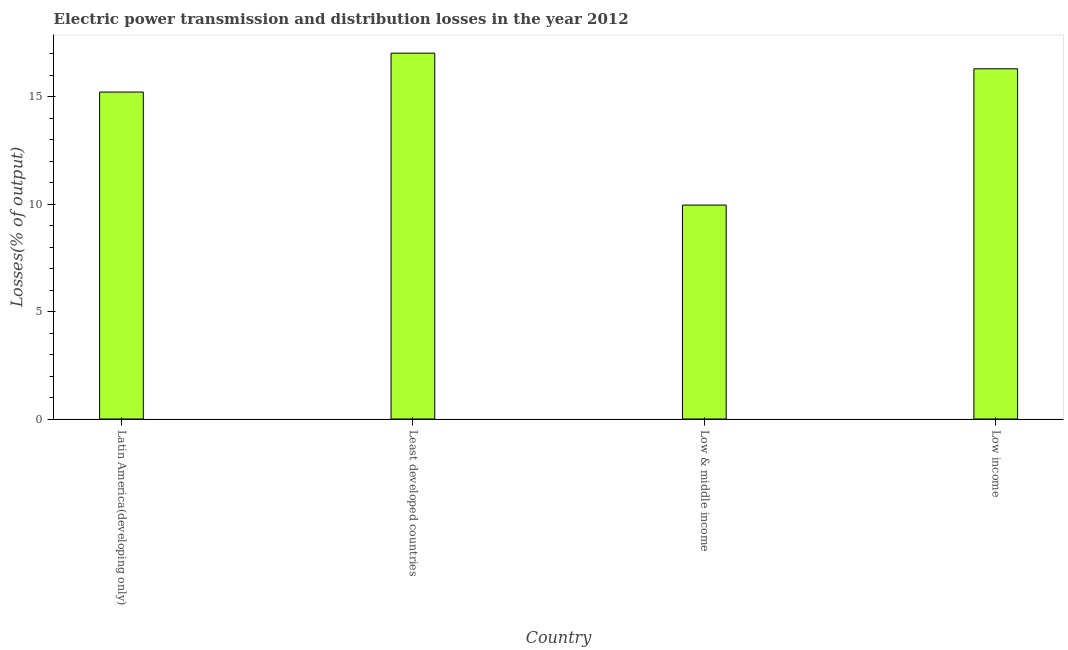Does the graph contain any zero values?
Give a very brief answer. No. What is the title of the graph?
Make the answer very short. Electric power transmission and distribution losses in the year 2012. What is the label or title of the Y-axis?
Offer a very short reply. Losses(% of output). What is the electric power transmission and distribution losses in Latin America(developing only)?
Give a very brief answer. 15.21. Across all countries, what is the maximum electric power transmission and distribution losses?
Keep it short and to the point. 17.02. Across all countries, what is the minimum electric power transmission and distribution losses?
Your response must be concise. 9.95. In which country was the electric power transmission and distribution losses maximum?
Make the answer very short. Least developed countries. In which country was the electric power transmission and distribution losses minimum?
Your answer should be very brief. Low & middle income. What is the sum of the electric power transmission and distribution losses?
Your response must be concise. 58.47. What is the difference between the electric power transmission and distribution losses in Low & middle income and Low income?
Your response must be concise. -6.34. What is the average electric power transmission and distribution losses per country?
Your answer should be very brief. 14.62. What is the median electric power transmission and distribution losses?
Your response must be concise. 15.75. In how many countries, is the electric power transmission and distribution losses greater than 15 %?
Provide a short and direct response. 3. What is the ratio of the electric power transmission and distribution losses in Low & middle income to that in Low income?
Provide a short and direct response. 0.61. Is the electric power transmission and distribution losses in Latin America(developing only) less than that in Low income?
Keep it short and to the point. Yes. Is the difference between the electric power transmission and distribution losses in Latin America(developing only) and Least developed countries greater than the difference between any two countries?
Keep it short and to the point. No. What is the difference between the highest and the second highest electric power transmission and distribution losses?
Offer a very short reply. 0.73. What is the difference between the highest and the lowest electric power transmission and distribution losses?
Your answer should be compact. 7.07. Are all the bars in the graph horizontal?
Your answer should be compact. No. Are the values on the major ticks of Y-axis written in scientific E-notation?
Make the answer very short. No. What is the Losses(% of output) of Latin America(developing only)?
Your answer should be very brief. 15.21. What is the Losses(% of output) in Least developed countries?
Your answer should be very brief. 17.02. What is the Losses(% of output) of Low & middle income?
Offer a very short reply. 9.95. What is the Losses(% of output) of Low income?
Ensure brevity in your answer.  16.29. What is the difference between the Losses(% of output) in Latin America(developing only) and Least developed countries?
Offer a terse response. -1.81. What is the difference between the Losses(% of output) in Latin America(developing only) and Low & middle income?
Make the answer very short. 5.26. What is the difference between the Losses(% of output) in Latin America(developing only) and Low income?
Make the answer very short. -1.08. What is the difference between the Losses(% of output) in Least developed countries and Low & middle income?
Offer a very short reply. 7.07. What is the difference between the Losses(% of output) in Least developed countries and Low income?
Provide a short and direct response. 0.73. What is the difference between the Losses(% of output) in Low & middle income and Low income?
Provide a succinct answer. -6.34. What is the ratio of the Losses(% of output) in Latin America(developing only) to that in Least developed countries?
Your response must be concise. 0.89. What is the ratio of the Losses(% of output) in Latin America(developing only) to that in Low & middle income?
Offer a very short reply. 1.53. What is the ratio of the Losses(% of output) in Latin America(developing only) to that in Low income?
Make the answer very short. 0.93. What is the ratio of the Losses(% of output) in Least developed countries to that in Low & middle income?
Provide a succinct answer. 1.71. What is the ratio of the Losses(% of output) in Least developed countries to that in Low income?
Make the answer very short. 1.04. What is the ratio of the Losses(% of output) in Low & middle income to that in Low income?
Keep it short and to the point. 0.61. 